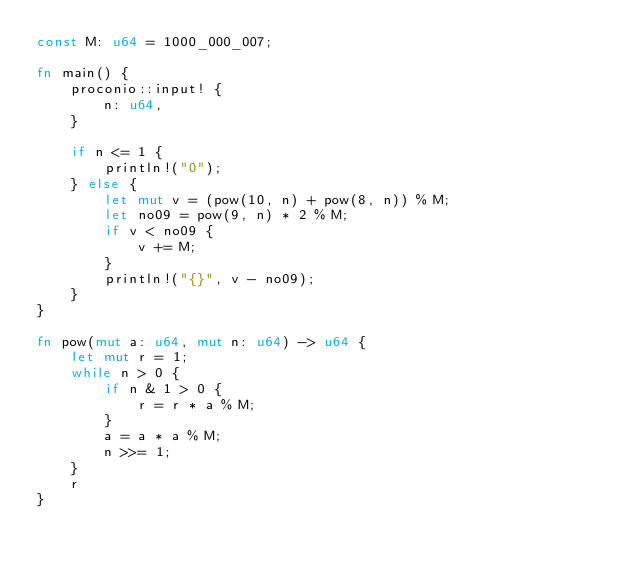<code> <loc_0><loc_0><loc_500><loc_500><_Rust_>const M: u64 = 1000_000_007;

fn main() {
    proconio::input! {
        n: u64,
    }

    if n <= 1 {
        println!("0");
    } else {
        let mut v = (pow(10, n) + pow(8, n)) % M;
        let no09 = pow(9, n) * 2 % M;
        if v < no09 {
            v += M;
        }
        println!("{}", v - no09);
    }
}

fn pow(mut a: u64, mut n: u64) -> u64 {
    let mut r = 1;
    while n > 0 {
        if n & 1 > 0 {
            r = r * a % M;
        }
        a = a * a % M;
        n >>= 1;
    }
    r
}
</code> 